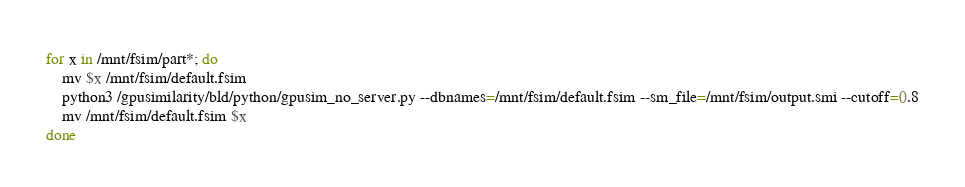<code> <loc_0><loc_0><loc_500><loc_500><_Bash_>for x in /mnt/fsim/part*; do
    mv $x /mnt/fsim/default.fsim
    python3 /gpusimilarity/bld/python/gpusim_no_server.py --dbnames=/mnt/fsim/default.fsim --sm_file=/mnt/fsim/output.smi --cutoff=0.8
    mv /mnt/fsim/default.fsim $x
done
</code> 